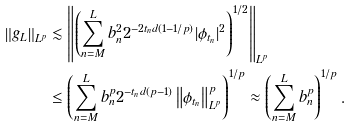Convert formula to latex. <formula><loc_0><loc_0><loc_500><loc_500>\left \| g _ { L } \right \| _ { L ^ { p } } & \lesssim \left \| \left ( \sum _ { n = M } ^ { L } { b _ { n } ^ { 2 } 2 ^ { - 2 t _ { n } d ( 1 - 1 / p ) } | \phi _ { t _ { n } } | ^ { 2 } } \right ) ^ { 1 / 2 } \right \| _ { L ^ { p } } \\ & \leq \left ( \sum _ { n = M } ^ { L } { b _ { n } ^ { p } 2 ^ { - { t _ { n } } d ( p - 1 ) } \left \| \phi _ { t _ { n } } \right \| _ { L ^ { p } } ^ { p } } \right ) ^ { { 1 } / { p } } \approx \left ( \sum _ { n = M } ^ { L } { b _ { n } ^ { p } } \right ) ^ { { 1 } / { p } } .</formula> 